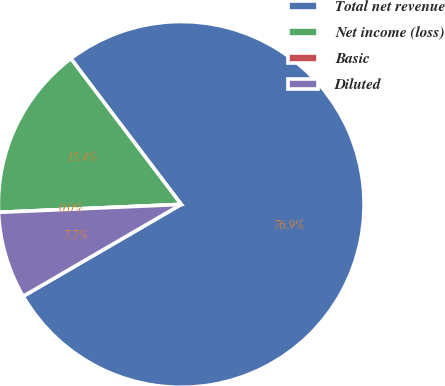<chart> <loc_0><loc_0><loc_500><loc_500><pie_chart><fcel>Total net revenue<fcel>Net income (loss)<fcel>Basic<fcel>Diluted<nl><fcel>76.92%<fcel>15.38%<fcel>0.0%<fcel>7.69%<nl></chart> 